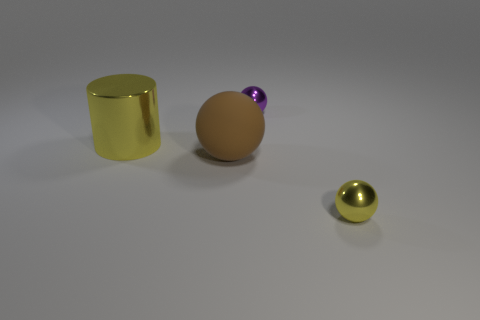Subtract all tiny spheres. How many spheres are left? 1 Subtract all yellow balls. How many balls are left? 2 Subtract all balls. How many objects are left? 1 Subtract 1 cylinders. How many cylinders are left? 0 Add 3 small purple balls. How many small purple balls are left? 4 Add 3 big brown spheres. How many big brown spheres exist? 4 Add 1 metal cylinders. How many objects exist? 5 Subtract 1 yellow cylinders. How many objects are left? 3 Subtract all red cylinders. Subtract all red spheres. How many cylinders are left? 1 Subtract all blue cylinders. How many gray balls are left? 0 